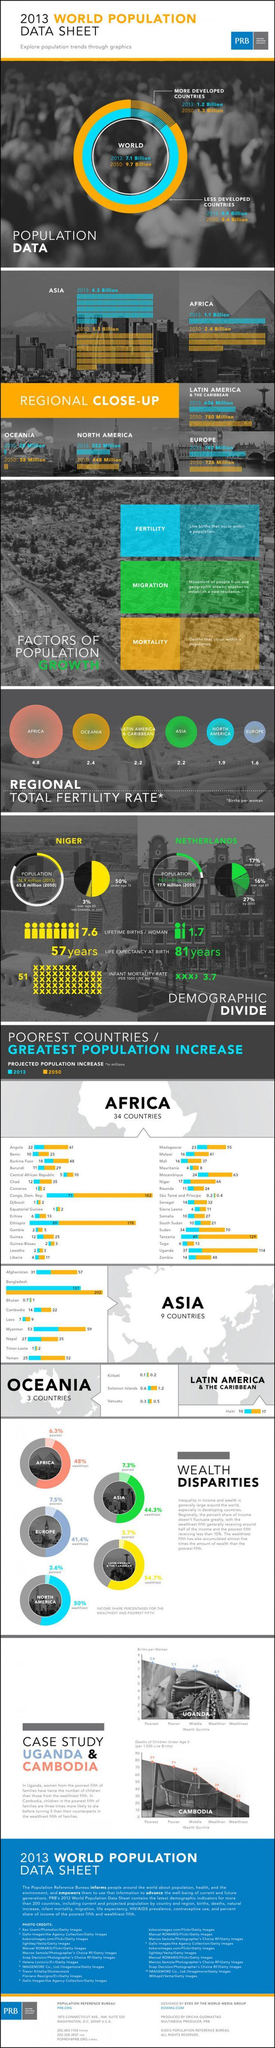Highlight a few significant elements in this photo. According to projections, the population of Tanzania is expected to increase by approximately 129 million people by 2050. By 2050, the projected population increase of Ethiopia is expected to reach approximately 178 million people. According to data, the continent with the highest fertility rate is Africa. According to the data, Bhutan is the Asian country with the lowest estimated population growth. The projected population increase of Afghanistan by 2050 is estimated to be approximately 57 million. 